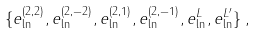<formula> <loc_0><loc_0><loc_500><loc_500>\{ e _ { \ln } ^ { ( 2 , 2 ) } , e _ { \ln } ^ { ( 2 , - 2 ) } , e _ { \ln } ^ { ( 2 , 1 ) } , e _ { \ln } ^ { ( 2 , - 1 ) } , e _ { \ln } ^ { L } , e _ { \ln } ^ { L ^ { \prime } } \} \, ,</formula> 